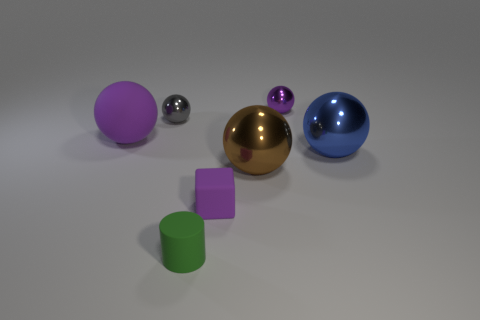Is the shape of the purple object that is in front of the big purple object the same as the matte object that is behind the brown sphere?
Your response must be concise. No. What shape is the rubber object that is the same size as the green matte cylinder?
Keep it short and to the point. Cube. Do the purple ball that is left of the brown shiny thing and the small purple object that is behind the blue metal thing have the same material?
Offer a very short reply. No. There is a purple ball to the right of the big purple ball; is there a tiny cube behind it?
Keep it short and to the point. No. What is the color of the other large object that is made of the same material as the blue thing?
Offer a terse response. Brown. Is the number of tiny metallic things greater than the number of purple blocks?
Offer a terse response. Yes. What number of objects are spheres that are to the right of the gray ball or purple matte blocks?
Keep it short and to the point. 4. Are there any matte spheres that have the same size as the brown metallic thing?
Provide a short and direct response. Yes. Are there fewer tiny gray metallic balls than big brown blocks?
Provide a succinct answer. No. What number of spheres are either large blue metal objects or small purple things?
Give a very brief answer. 2. 